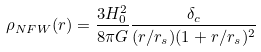Convert formula to latex. <formula><loc_0><loc_0><loc_500><loc_500>\rho _ { N F W } ( r ) = \frac { 3 H _ { 0 } ^ { 2 } } { 8 \pi G } \frac { \delta _ { c } } { ( r / r _ { s } ) ( 1 + r / r _ { s } ) ^ { 2 } }</formula> 